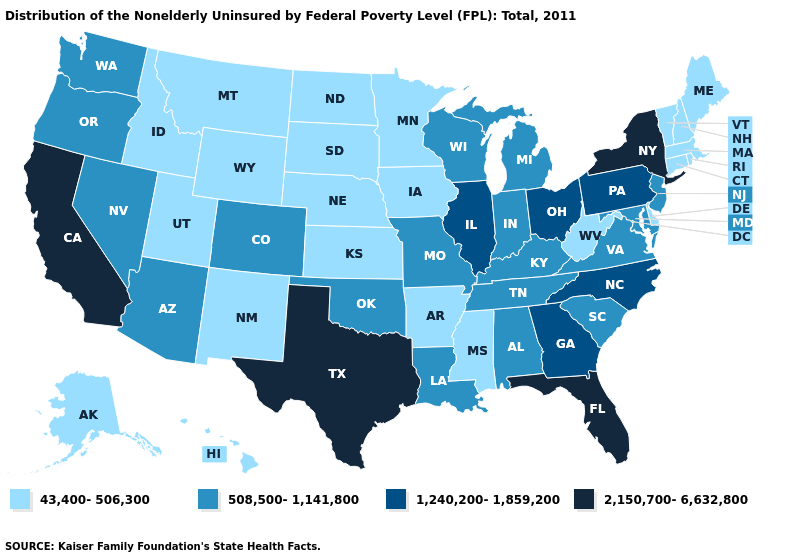Does North Dakota have the same value as Texas?
Be succinct. No. Which states have the lowest value in the USA?
Be succinct. Alaska, Arkansas, Connecticut, Delaware, Hawaii, Idaho, Iowa, Kansas, Maine, Massachusetts, Minnesota, Mississippi, Montana, Nebraska, New Hampshire, New Mexico, North Dakota, Rhode Island, South Dakota, Utah, Vermont, West Virginia, Wyoming. What is the highest value in the USA?
Quick response, please. 2,150,700-6,632,800. What is the value of Wyoming?
Write a very short answer. 43,400-506,300. Among the states that border New Mexico , does Texas have the highest value?
Short answer required. Yes. Does the map have missing data?
Short answer required. No. Which states hav the highest value in the Northeast?
Quick response, please. New York. Does Montana have a higher value than New Hampshire?
Answer briefly. No. Name the states that have a value in the range 2,150,700-6,632,800?
Keep it brief. California, Florida, New York, Texas. Name the states that have a value in the range 43,400-506,300?
Give a very brief answer. Alaska, Arkansas, Connecticut, Delaware, Hawaii, Idaho, Iowa, Kansas, Maine, Massachusetts, Minnesota, Mississippi, Montana, Nebraska, New Hampshire, New Mexico, North Dakota, Rhode Island, South Dakota, Utah, Vermont, West Virginia, Wyoming. Does Mississippi have the highest value in the USA?
Give a very brief answer. No. Name the states that have a value in the range 1,240,200-1,859,200?
Short answer required. Georgia, Illinois, North Carolina, Ohio, Pennsylvania. Does the first symbol in the legend represent the smallest category?
Short answer required. Yes. Among the states that border Nevada , does Arizona have the highest value?
Answer briefly. No. 